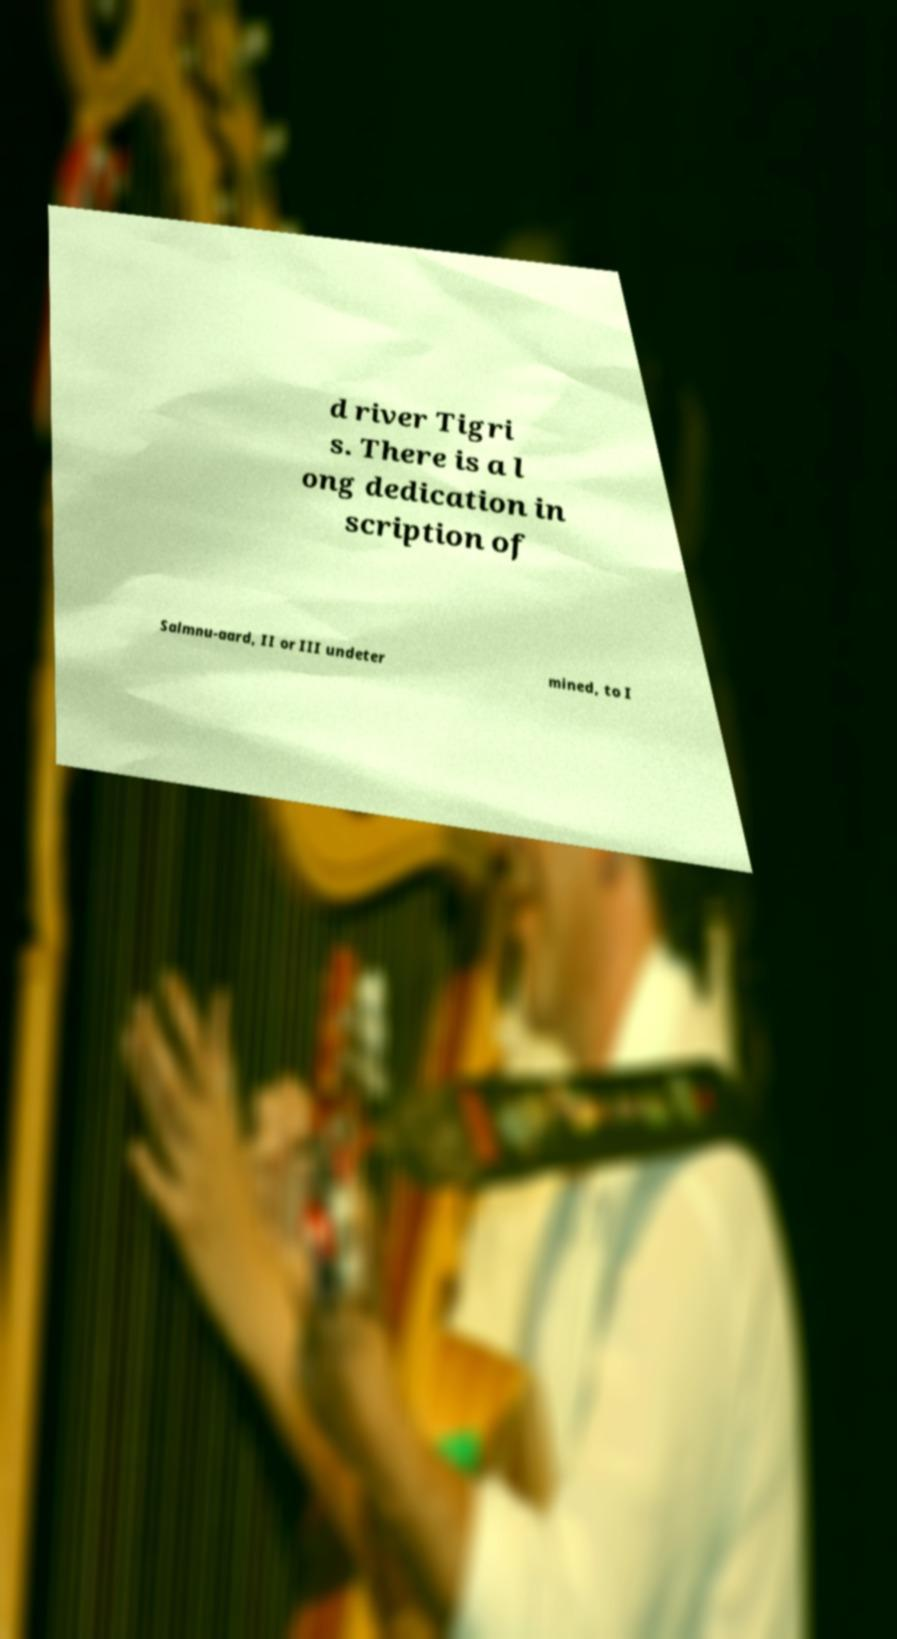Please read and relay the text visible in this image. What does it say? d river Tigri s. There is a l ong dedication in scription of Salmnu-aard, II or III undeter mined, to I 